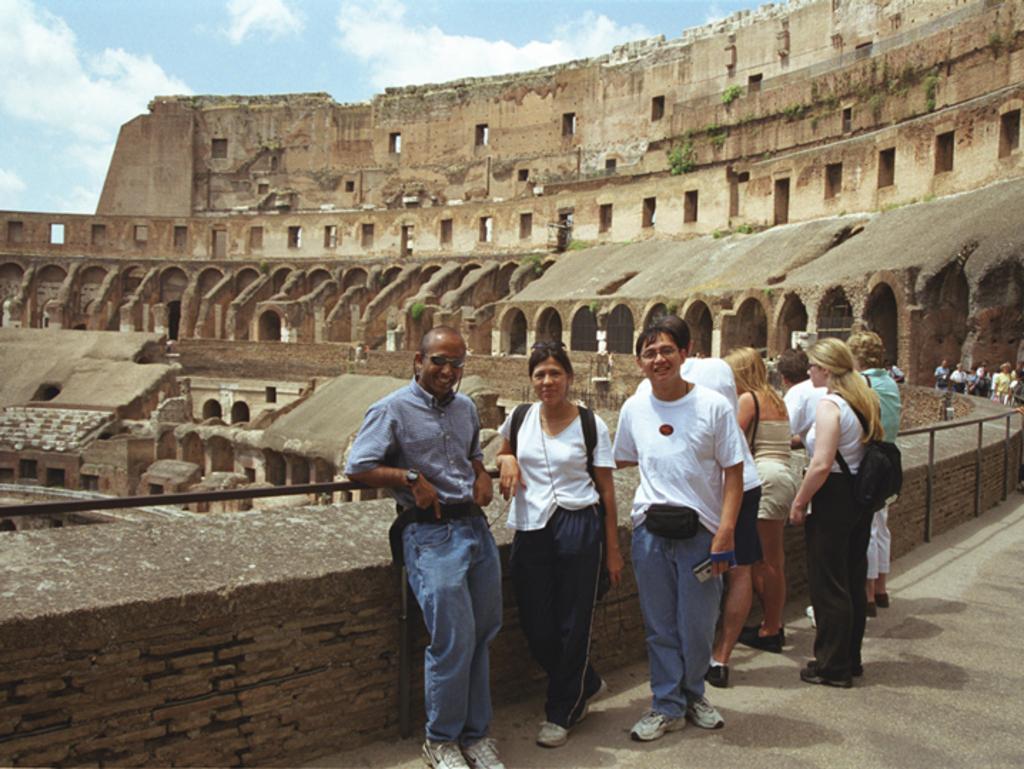Could you give a brief overview of what you see in this image? In this age I can see the group of people with different color dresses. I can see few people are wearing the bags. These people are standing in-front of the railing. In the back I can see the fort. I can also see the clouds and the sky in the back. 